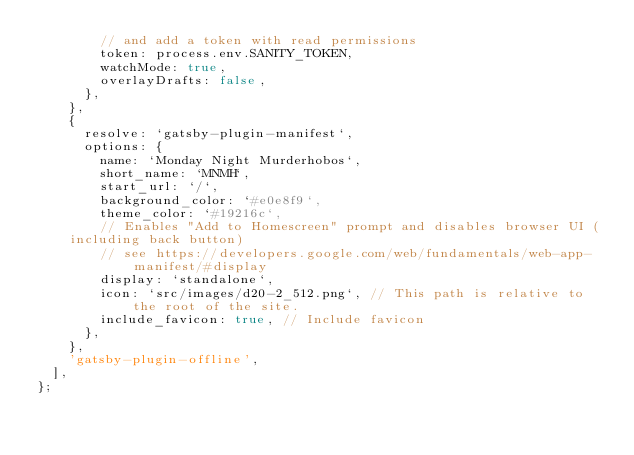<code> <loc_0><loc_0><loc_500><loc_500><_JavaScript_>        // and add a token with read permissions
        token: process.env.SANITY_TOKEN,
        watchMode: true,
        overlayDrafts: false,
      },
    },
    {
      resolve: `gatsby-plugin-manifest`,
      options: {
        name: `Monday Night Murderhobos`,
        short_name: `MNMH`,
        start_url: `/`,
        background_color: `#e0e8f9`,
        theme_color: `#19216c`,
        // Enables "Add to Homescreen" prompt and disables browser UI (including back button)
        // see https://developers.google.com/web/fundamentals/web-app-manifest/#display
        display: `standalone`,
        icon: `src/images/d20-2_512.png`, // This path is relative to the root of the site.
        include_favicon: true, // Include favicon
      },
    },
    'gatsby-plugin-offline',
  ],
};
</code> 